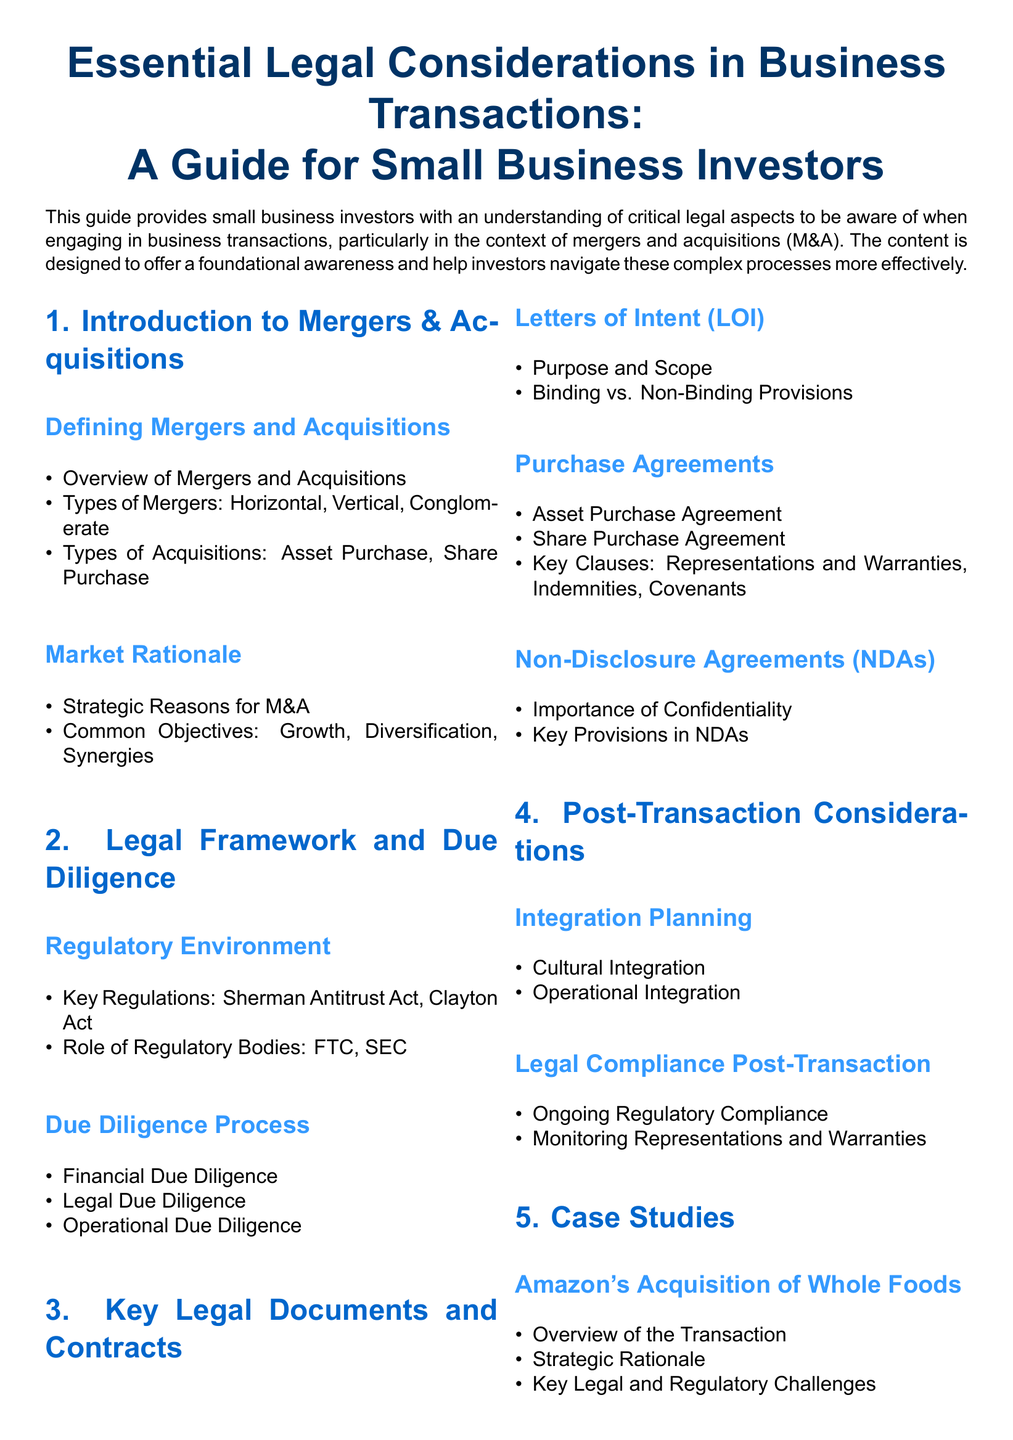What is the purpose of the guide? The guide provides small business investors with an understanding of critical legal aspects to be aware of when engaging in business transactions, particularly in the context of mergers and acquisitions.
Answer: Understanding critical legal aspects What is the first section about? The first section is titled "Introduction to Mergers & Acquisitions" and covers definitions and market rationale related to M&A.
Answer: Introduction to Mergers & Acquisitions Name one type of merger mentioned in the document. The document lists types of mergers including horizontal, vertical, and conglomerate.
Answer: Horizontal What regulatory acts are key in the legal framework? The key regulations mentioned are the Sherman Antitrust Act and the Clayton Act.
Answer: Sherman Antitrust Act, Clayton Act What is a key aspect of due diligence listed in the document? The document highlights financial due diligence, legal due diligence, and operational due diligence as key aspects.
Answer: Financial due diligence What is the purpose of a Letter of Intent (LOI)? The purpose of a Letter of Intent is to outline the scope and intention in the early stages of a business transaction.
Answer: Outline the scope and intention What is one legal document used in acquisitions? The document mentions both Asset Purchase Agreements and Share Purchase Agreements as legal documents used in acquisitions.
Answer: Asset Purchase Agreement Which company's acquisition of Whole Foods is mentioned as a case study? The document states that Amazon's acquisition of Whole Foods is a case study included.
Answer: Amazon's acquisition of Whole Foods What does the conclusion section summarize? The conclusion section summarizes essential takeaways regarding key legal considerations and the importance of seeking professional advice.
Answer: Key legal considerations and the importance of professional advice 